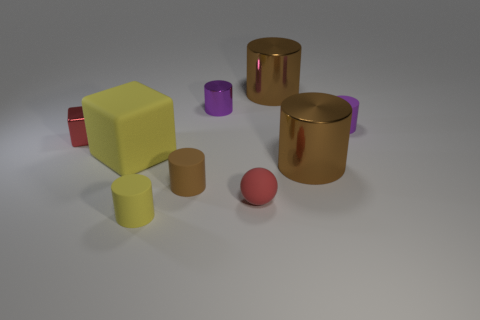Subtract all yellow balls. How many brown cylinders are left? 3 Subtract 3 cylinders. How many cylinders are left? 3 Subtract all yellow cylinders. How many cylinders are left? 5 Subtract all small brown matte cylinders. How many cylinders are left? 5 Subtract all blue cylinders. Subtract all cyan blocks. How many cylinders are left? 6 Add 1 large cyan rubber cylinders. How many objects exist? 10 Subtract all balls. How many objects are left? 8 Subtract all small gray blocks. Subtract all small red rubber spheres. How many objects are left? 8 Add 1 tiny metallic blocks. How many tiny metallic blocks are left? 2 Add 9 tiny gray rubber objects. How many tiny gray rubber objects exist? 9 